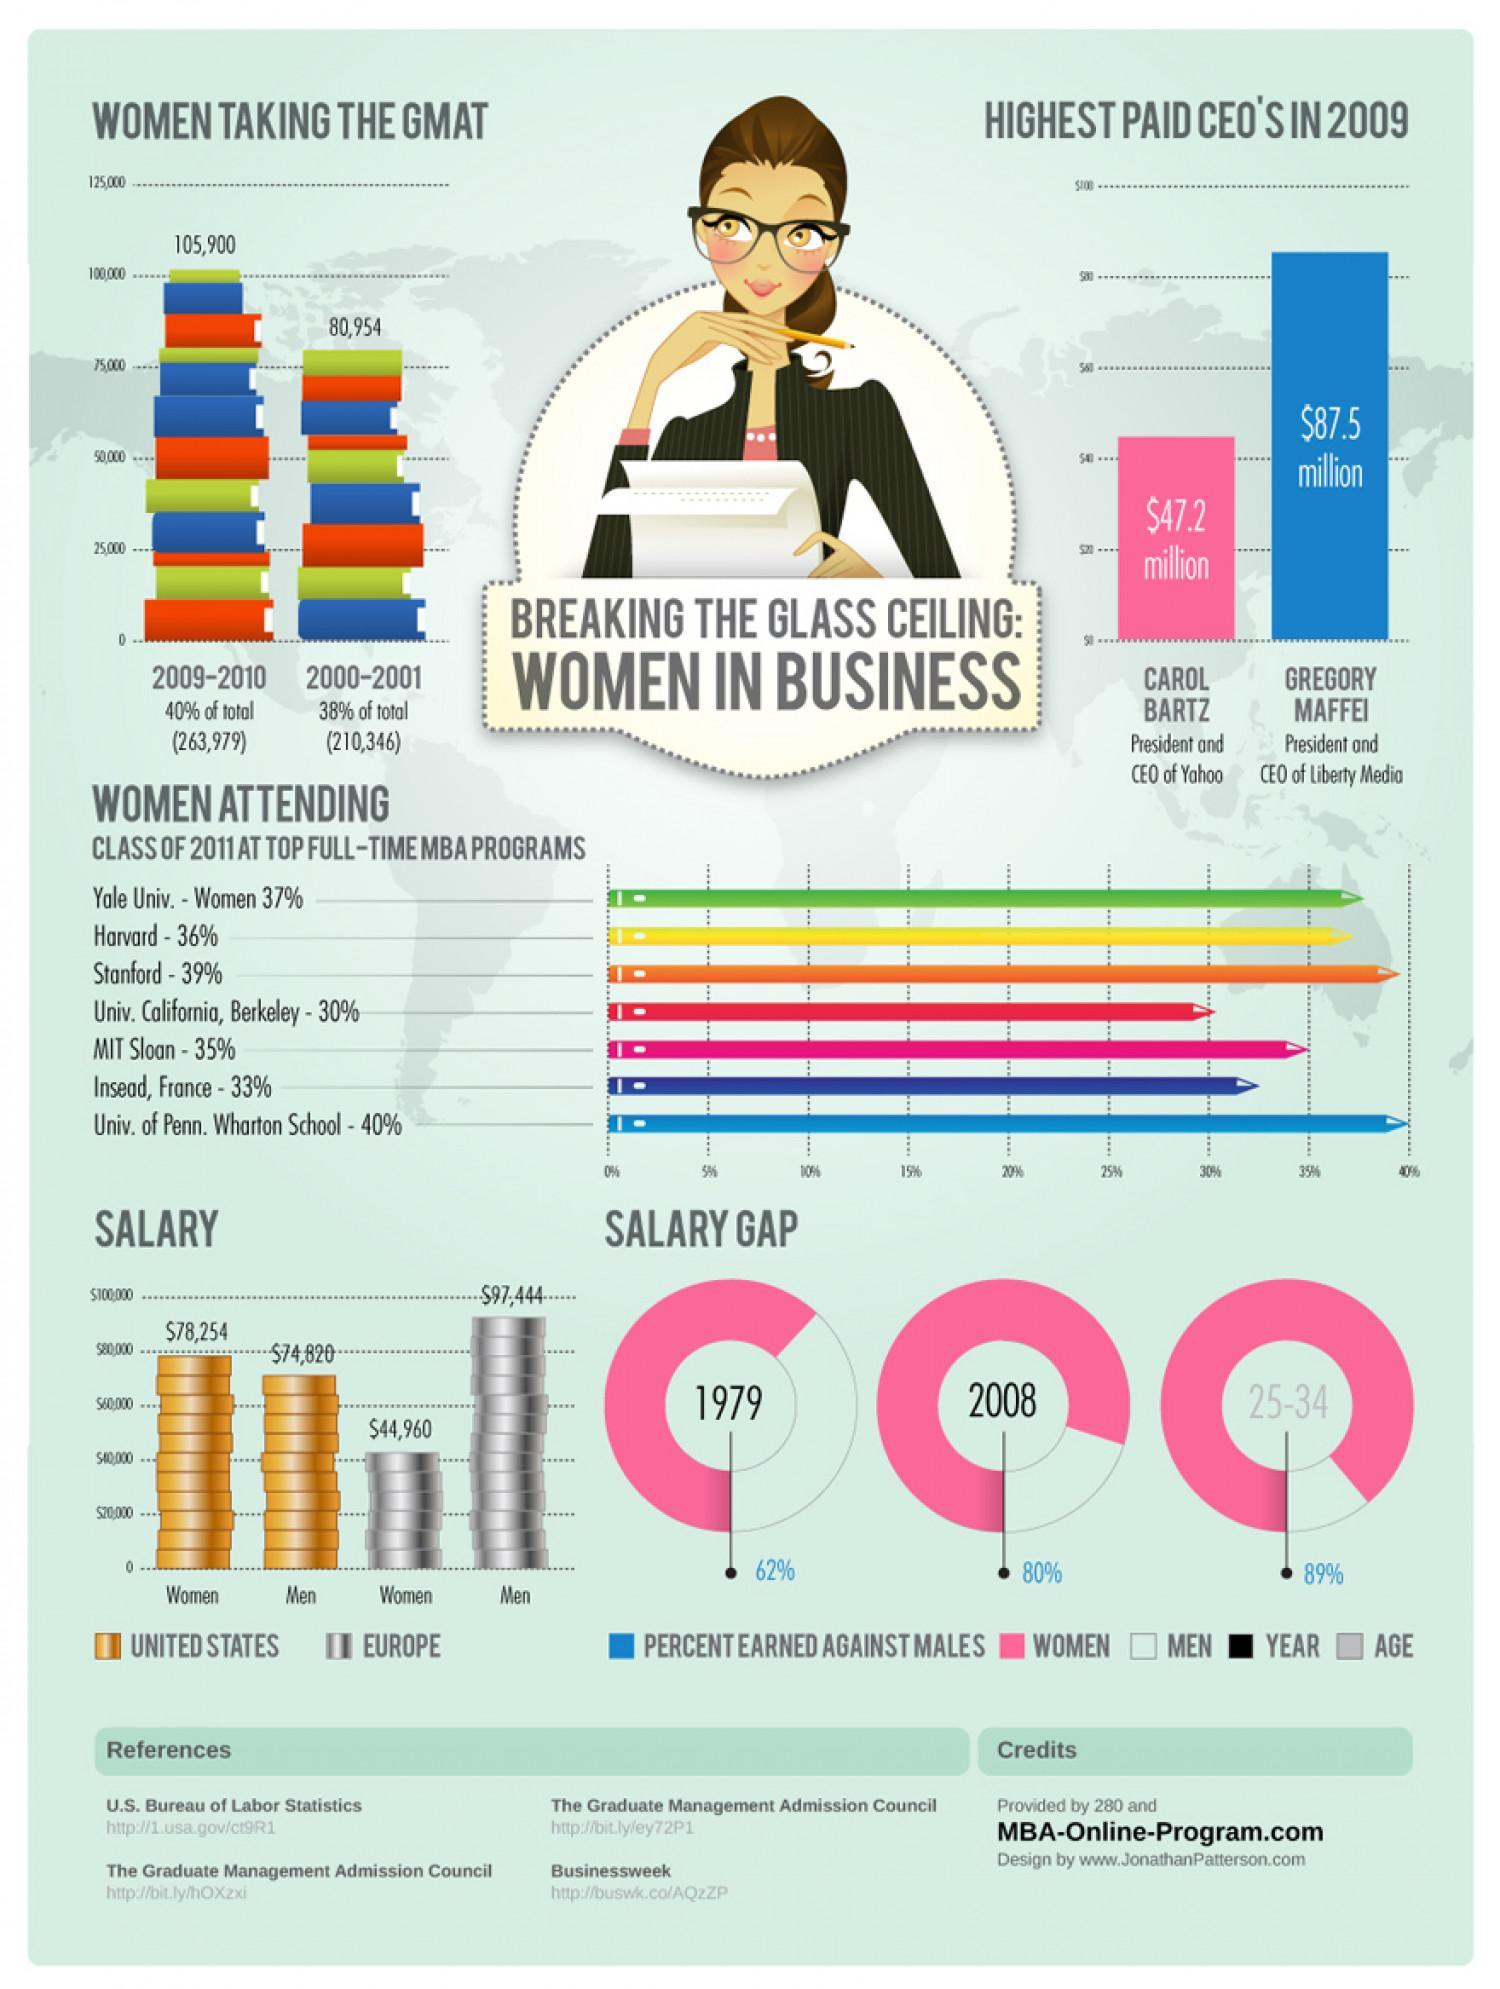What is the difference between women taking the GMAT in 2009-2010 and 2000-2001?
Answer the question with a short phrase. 24946 What is the difference between the salary of Gregory Maffei and Carol Bartz in 2009? $40.3 What is the difference between the salary of men in Europe and the United States? $22624 What is the percentage of women attending the class of 2011 at the top full-time MBA programs at Harvard and Stanford, taken together? 75% What is the difference between the salary of women in the United States and Europe? $33294 What is the percentage of women attending the class of 2011 at the top full-time MBA programs at MIT Sloan and Stanford, taken together? 74% What is the difference between women taking the GMAT in 2009-2010 and 2000-2001 in percentage? 2% 